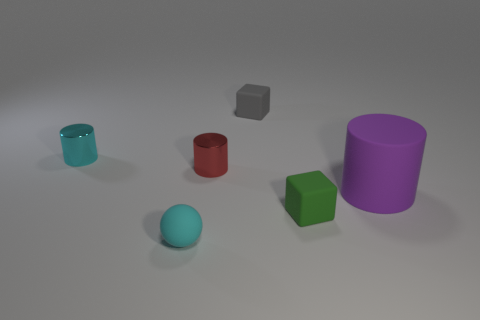Is the number of green cubes behind the green cube less than the number of tiny cylinders in front of the red object?
Offer a terse response. No. Is the number of rubber cubes greater than the number of green metallic cylinders?
Your response must be concise. Yes. What is the material of the red object?
Provide a succinct answer. Metal. What color is the small thing that is in front of the green object?
Your answer should be compact. Cyan. Is the number of small cyan cylinders that are on the right side of the tiny red shiny cylinder greater than the number of purple objects on the left side of the large cylinder?
Your response must be concise. No. There is a cyan object that is behind the green matte thing in front of the block that is on the left side of the green matte cube; what is its size?
Provide a short and direct response. Small. Are there any tiny balls that have the same color as the big cylinder?
Offer a very short reply. No. How many rubber things are there?
Provide a succinct answer. 4. There is a tiny block on the right side of the tiny rubber block behind the metallic object to the right of the tiny cyan rubber thing; what is it made of?
Provide a short and direct response. Rubber. Are there any other gray objects that have the same material as the small gray thing?
Provide a short and direct response. No. 